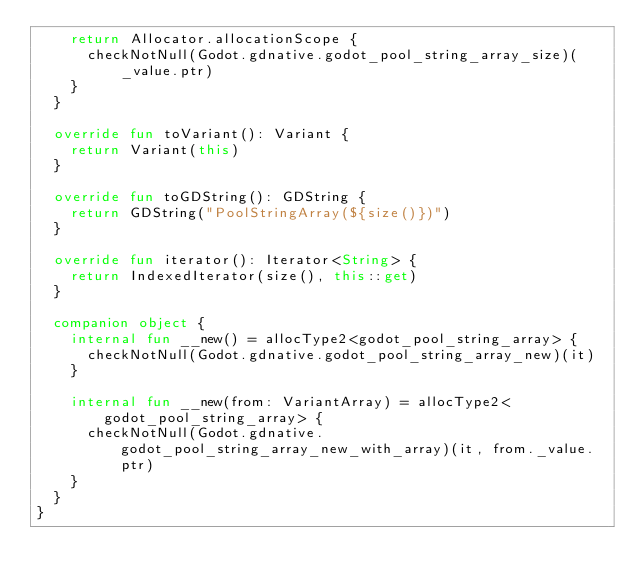Convert code to text. <code><loc_0><loc_0><loc_500><loc_500><_Kotlin_>    return Allocator.allocationScope {
      checkNotNull(Godot.gdnative.godot_pool_string_array_size)(_value.ptr)
    }
  }

  override fun toVariant(): Variant {
    return Variant(this)
  }

  override fun toGDString(): GDString {
    return GDString("PoolStringArray(${size()})")
  }

  override fun iterator(): Iterator<String> {
    return IndexedIterator(size(), this::get)
  }
  
  companion object {
    internal fun __new() = allocType2<godot_pool_string_array> {
      checkNotNull(Godot.gdnative.godot_pool_string_array_new)(it)
    }

    internal fun __new(from: VariantArray) = allocType2<godot_pool_string_array> {
      checkNotNull(Godot.gdnative.godot_pool_string_array_new_with_array)(it, from._value.ptr)
    }
  }
}
</code> 